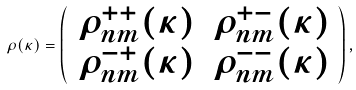<formula> <loc_0><loc_0><loc_500><loc_500>\rho ( \kappa ) = \left ( \begin{array} { c c c c } \rho ^ { + + } _ { n m } ( \kappa ) & \rho ^ { + - } _ { n m } ( \kappa ) \\ \rho ^ { - + } _ { n m } ( \kappa ) & \rho ^ { - - } _ { n m } ( \kappa ) \end{array} \right ) ,</formula> 